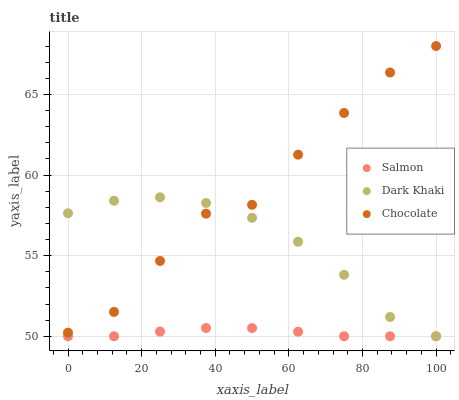Does Salmon have the minimum area under the curve?
Answer yes or no. Yes. Does Chocolate have the maximum area under the curve?
Answer yes or no. Yes. Does Chocolate have the minimum area under the curve?
Answer yes or no. No. Does Salmon have the maximum area under the curve?
Answer yes or no. No. Is Salmon the smoothest?
Answer yes or no. Yes. Is Chocolate the roughest?
Answer yes or no. Yes. Is Chocolate the smoothest?
Answer yes or no. No. Is Salmon the roughest?
Answer yes or no. No. Does Dark Khaki have the lowest value?
Answer yes or no. Yes. Does Chocolate have the lowest value?
Answer yes or no. No. Does Chocolate have the highest value?
Answer yes or no. Yes. Does Salmon have the highest value?
Answer yes or no. No. Is Salmon less than Chocolate?
Answer yes or no. Yes. Is Chocolate greater than Salmon?
Answer yes or no. Yes. Does Dark Khaki intersect Salmon?
Answer yes or no. Yes. Is Dark Khaki less than Salmon?
Answer yes or no. No. Is Dark Khaki greater than Salmon?
Answer yes or no. No. Does Salmon intersect Chocolate?
Answer yes or no. No. 